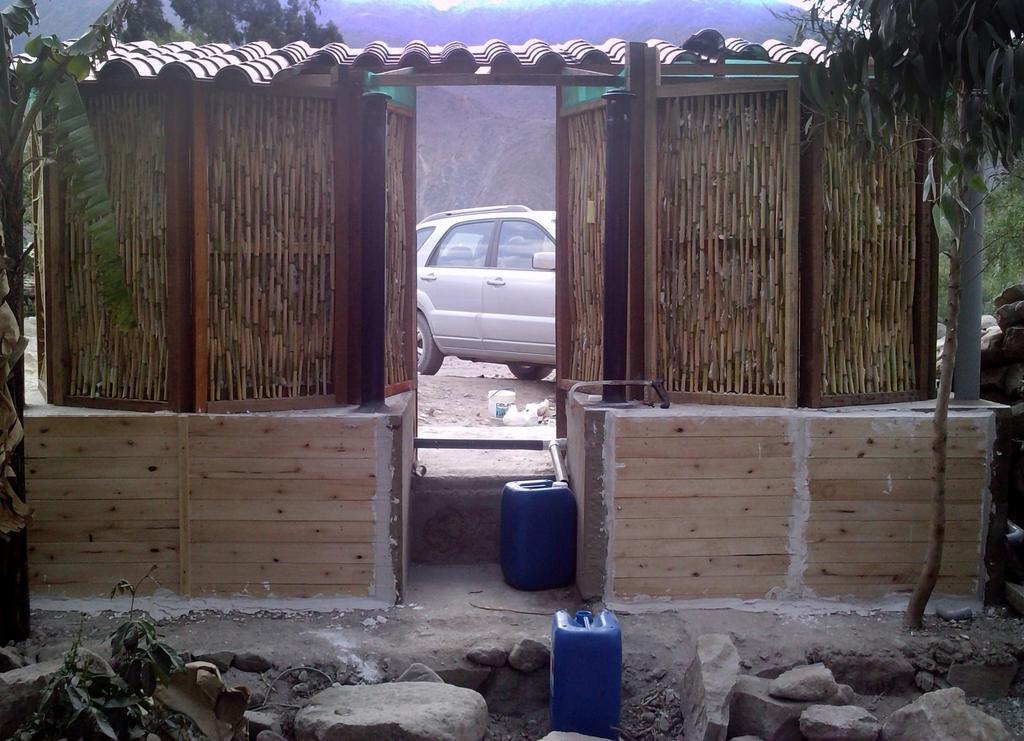Can you describe this image briefly? In this picture I can observe a car in the middle of the picture. I can observe two drums. In the bottom of the picture there are some stones. In the background I can observe hills and trees. 